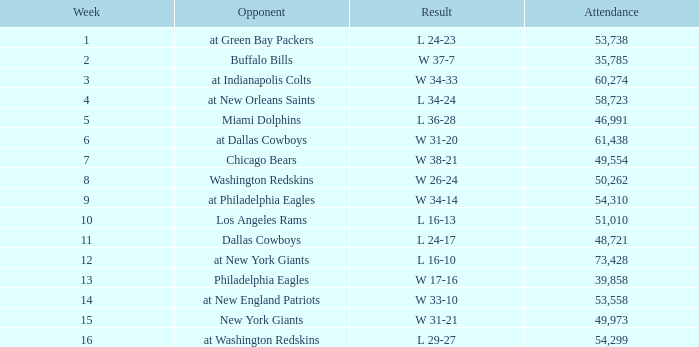What was the result in a week lower than 10 with an opponent of Chicago Bears? W 38-21. 